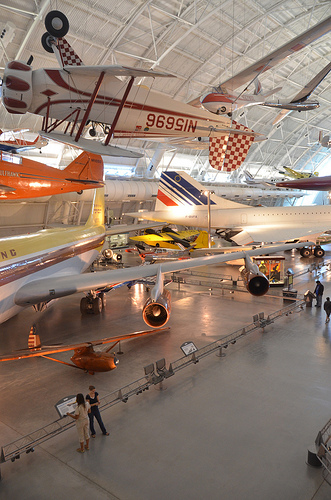<image>
Is the chair on the plane? No. The chair is not positioned on the plane. They may be near each other, but the chair is not supported by or resting on top of the plane. Is there a engine under the airplane? Yes. The engine is positioned underneath the airplane, with the airplane above it in the vertical space. 